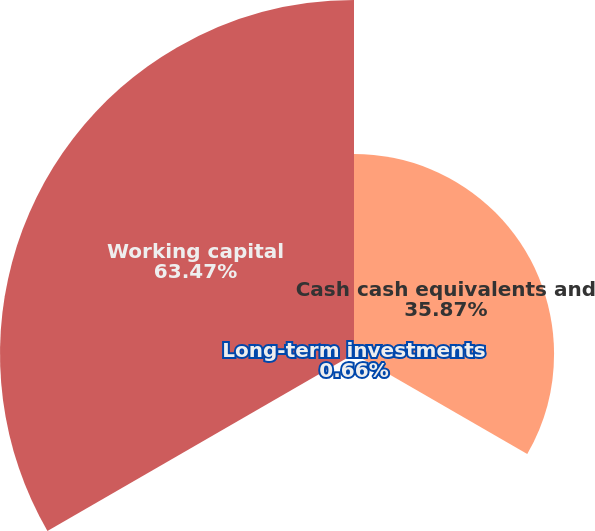Convert chart. <chart><loc_0><loc_0><loc_500><loc_500><pie_chart><fcel>Cash cash equivalents and<fcel>Long-term investments<fcel>Working capital<nl><fcel>35.87%<fcel>0.66%<fcel>63.47%<nl></chart> 